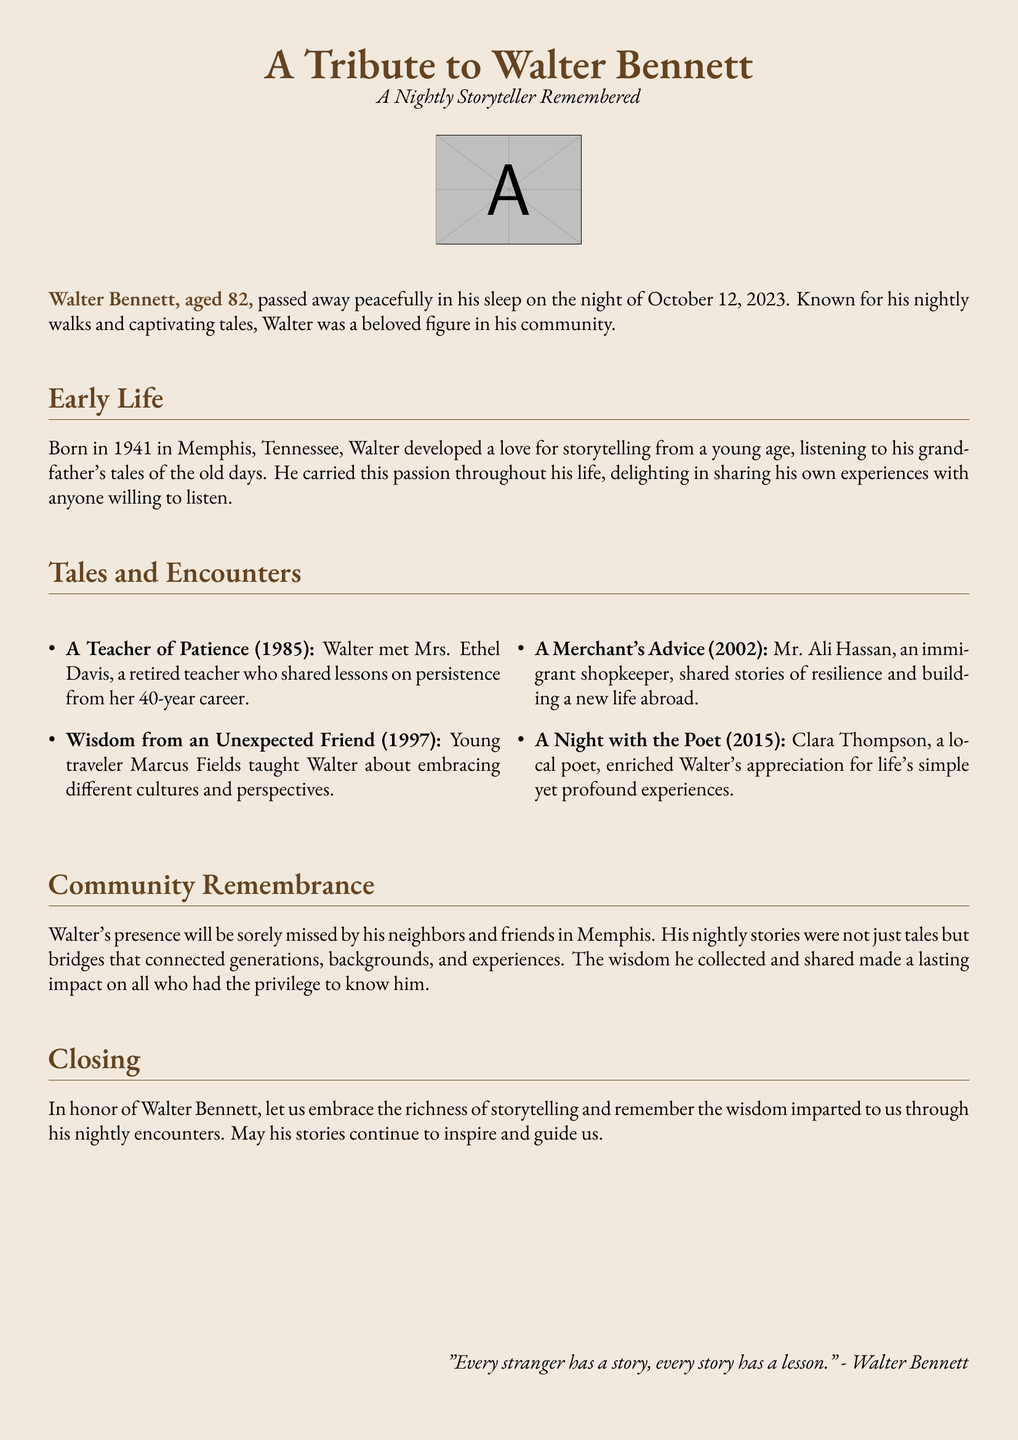What was Walter Bennett's age at the time of his passing? Walter's age is specified in the document as being 82 years old when he passed away.
Answer: 82 In what year did Walter pass away? The document states Walter passed away on October 12, 2023.
Answer: 2023 Who was the retired teacher Walter met? The document mentions Walter meeting Mrs. Ethel Davis, a retired teacher, which is key information regarding his encounters.
Answer: Mrs. Ethel Davis What was the profession of Mr. Ali Hassan? The document identifies Mr. Ali Hassan as an immigrant shopkeeper, indicating his background.
Answer: Shopkeeper What theme does Walter's story focus on throughout his life? The document highlights Walter's passion for storytelling as a central theme of his life experiences.
Answer: Storytelling Name one lesson Walter learned from Clara Thompson. The document notes that Clara Thompson, a local poet, enriched Walter's appreciation for life's simple yet profound experiences, reflecting the wisdom he gained.
Answer: Appreciation for life How did Walter Bennett contribute to his community? The document describes Walter's nightly stories as bridges connecting generations and backgrounds, indicating his role in community bonding.
Answer: Nightly stories What was the closing quote in honor of Walter? The document includes a quote attributed to Walter that summarizes his belief about storytelling and lessons from strangers.
Answer: "Every stranger has a story, every story has a lesson." What role did storytelling play in Walter's life? The document emphasizes that storytelling was a significant part of Walter's life, reflecting on the wisdom he gained from encounters.
Answer: Significant role 